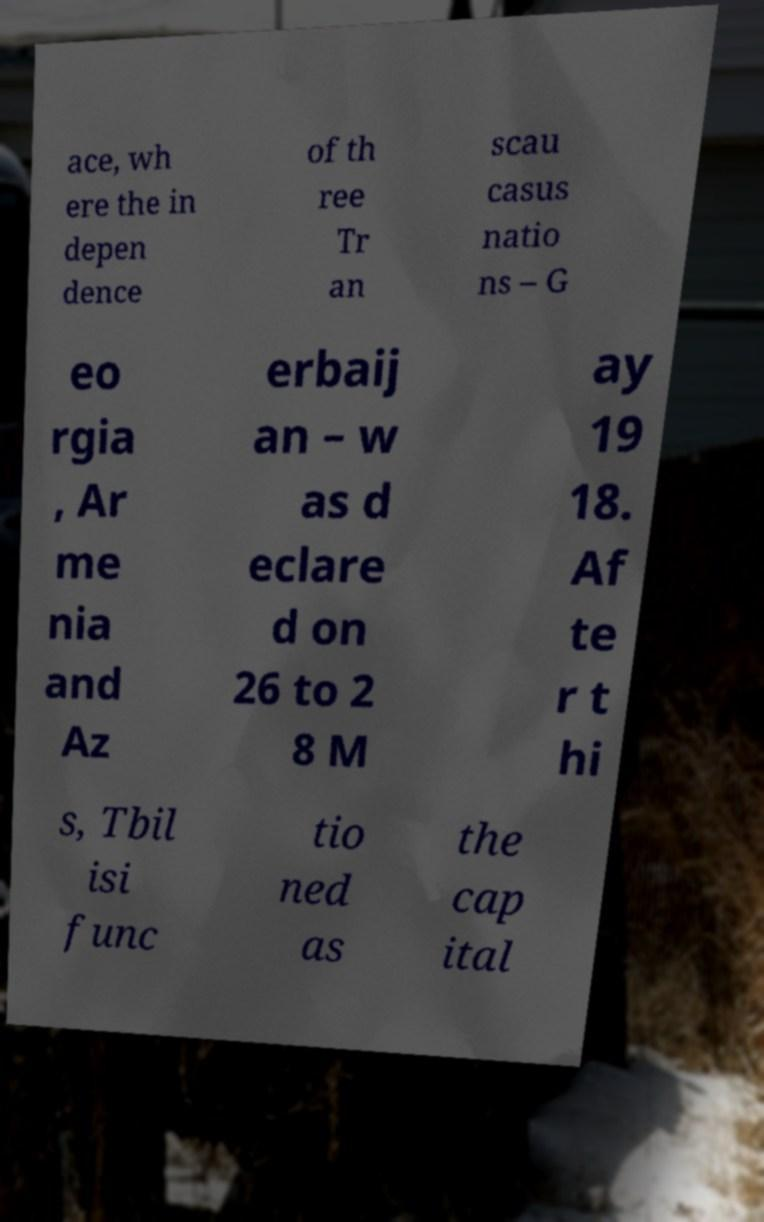I need the written content from this picture converted into text. Can you do that? ace, wh ere the in depen dence of th ree Tr an scau casus natio ns – G eo rgia , Ar me nia and Az erbaij an – w as d eclare d on 26 to 2 8 M ay 19 18. Af te r t hi s, Tbil isi func tio ned as the cap ital 